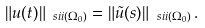Convert formula to latex. <formula><loc_0><loc_0><loc_500><loc_500>\| u ( t ) \| _ { \ s i i ( \Omega _ { 0 } ) } = \| \tilde { u } ( s ) \| _ { \ s i i ( \Omega _ { 0 } ) } \, .</formula> 